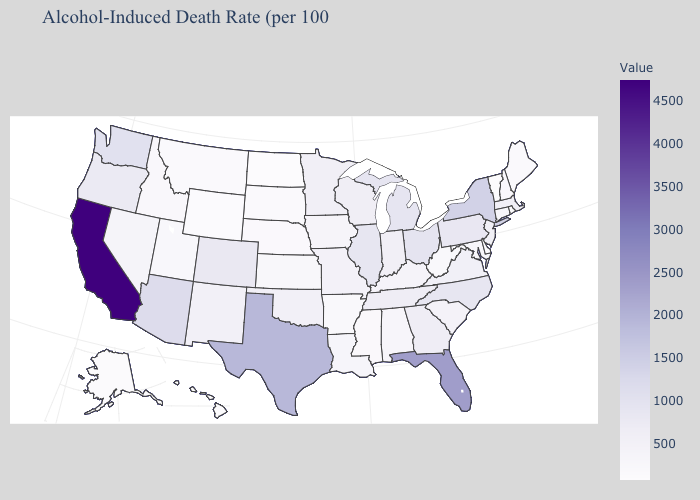Among the states that border Virginia , does North Carolina have the highest value?
Give a very brief answer. Yes. Does Delaware have the lowest value in the South?
Keep it brief. Yes. Among the states that border Kentucky , which have the lowest value?
Give a very brief answer. West Virginia. 